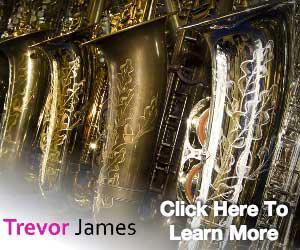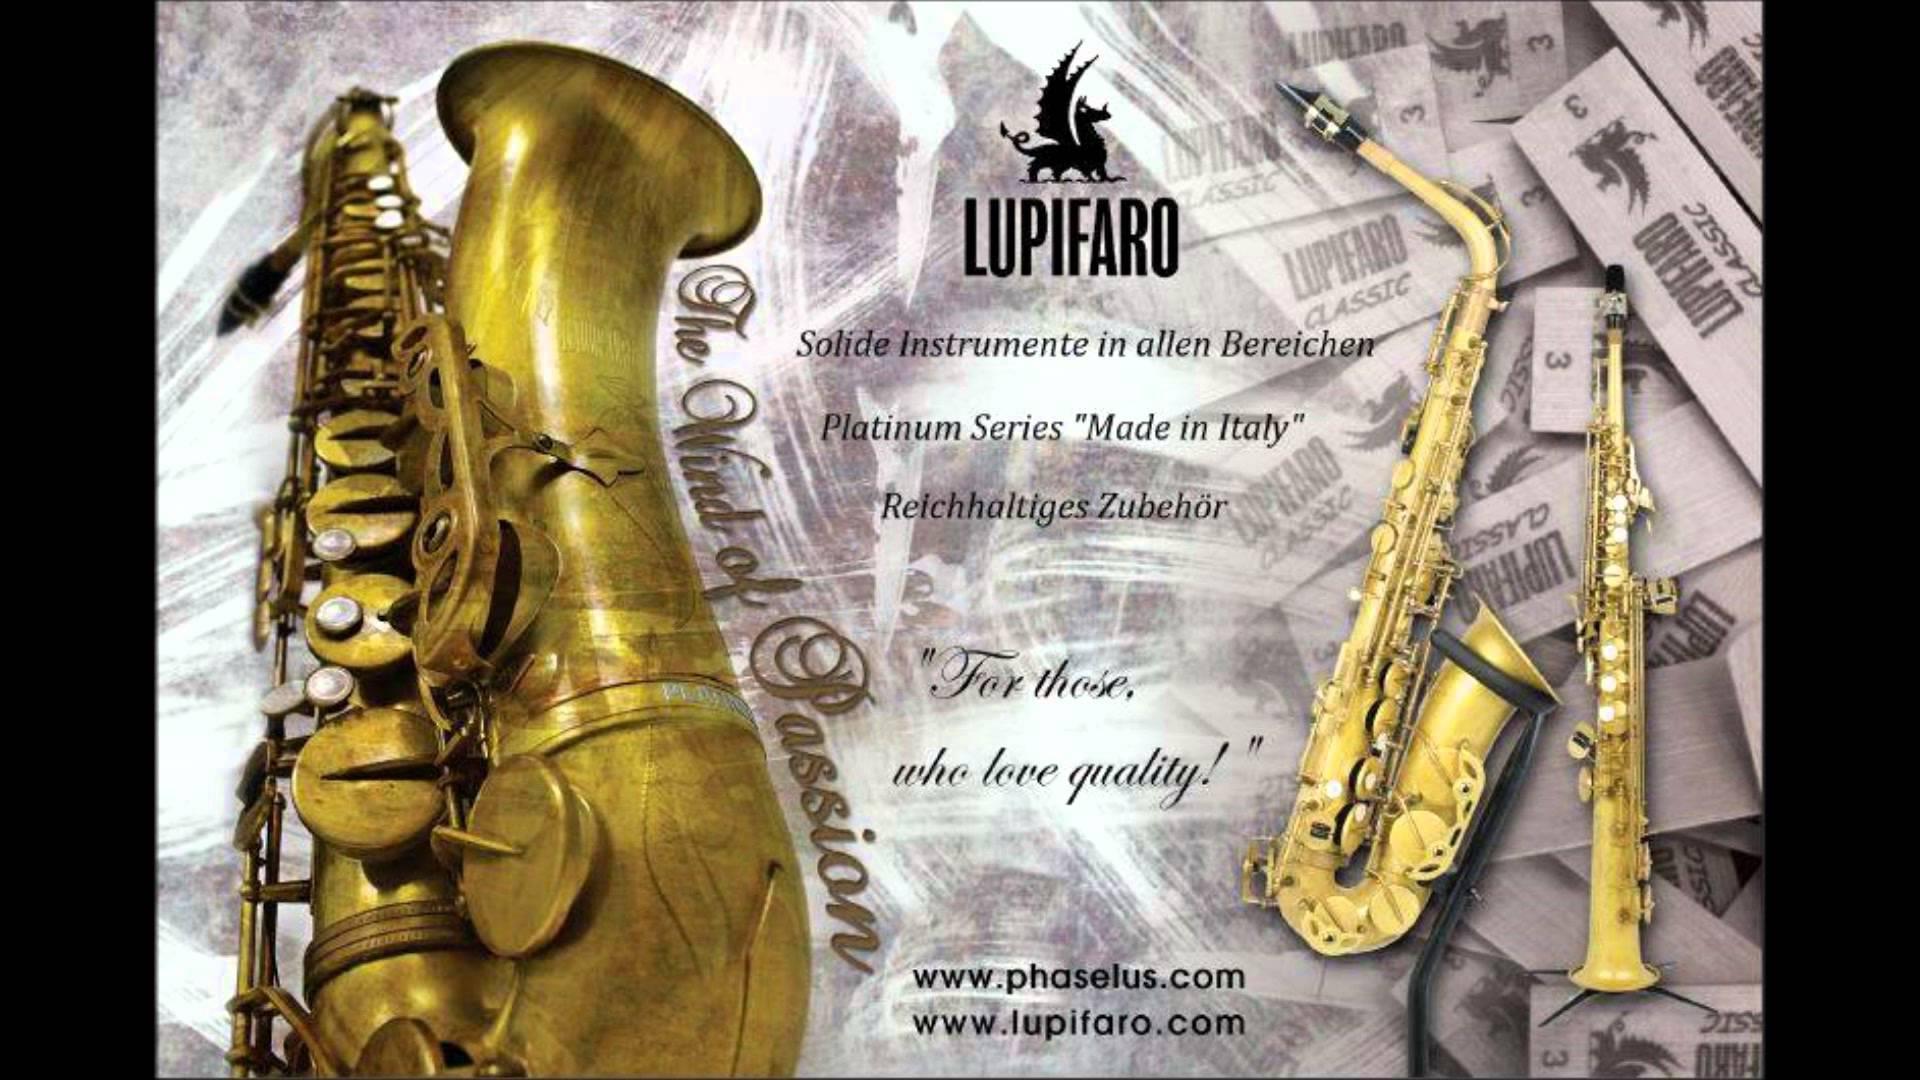The first image is the image on the left, the second image is the image on the right. Analyze the images presented: Is the assertion "The right image shows a dark saxophone with gold buttons displayed diagonally, with its mouthpiece at the upper left and its bell upturned." valid? Answer yes or no. No. The first image is the image on the left, the second image is the image on the right. Evaluate the accuracy of this statement regarding the images: "One of the sax's is inside its case.". Is it true? Answer yes or no. No. 